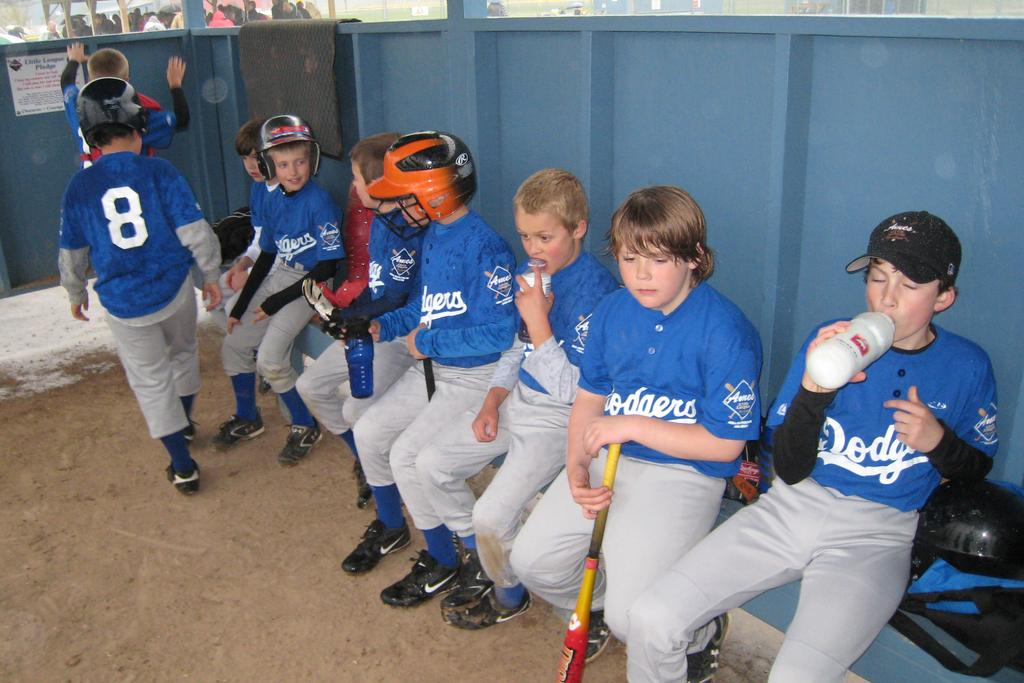<image>
Give a short and clear explanation of the subsequent image. Young boys wearing Dodgers jerseys sit in the dugout 